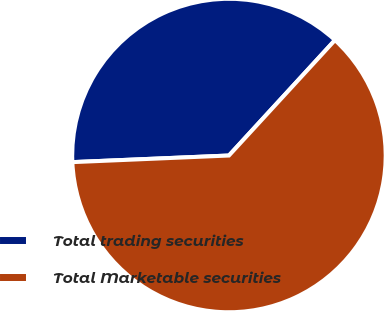Convert chart to OTSL. <chart><loc_0><loc_0><loc_500><loc_500><pie_chart><fcel>Total trading securities<fcel>Total Marketable securities<nl><fcel>37.5%<fcel>62.5%<nl></chart> 